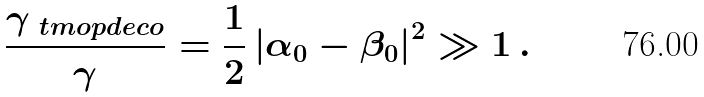<formula> <loc_0><loc_0><loc_500><loc_500>\frac { \gamma _ { \ t m o p { d e c o } } } { \gamma } = \frac { 1 } { 2 } \left | \alpha _ { 0 } - \beta _ { 0 } \right | ^ { 2 } \gg 1 \, .</formula> 